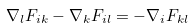Convert formula to latex. <formula><loc_0><loc_0><loc_500><loc_500>\nabla _ { l } F _ { i k } - \nabla _ { k } F _ { i l } = - \nabla _ { i } F _ { k l }</formula> 